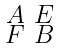<formula> <loc_0><loc_0><loc_500><loc_500>\begin{smallmatrix} A & E \\ F & B \end{smallmatrix}</formula> 